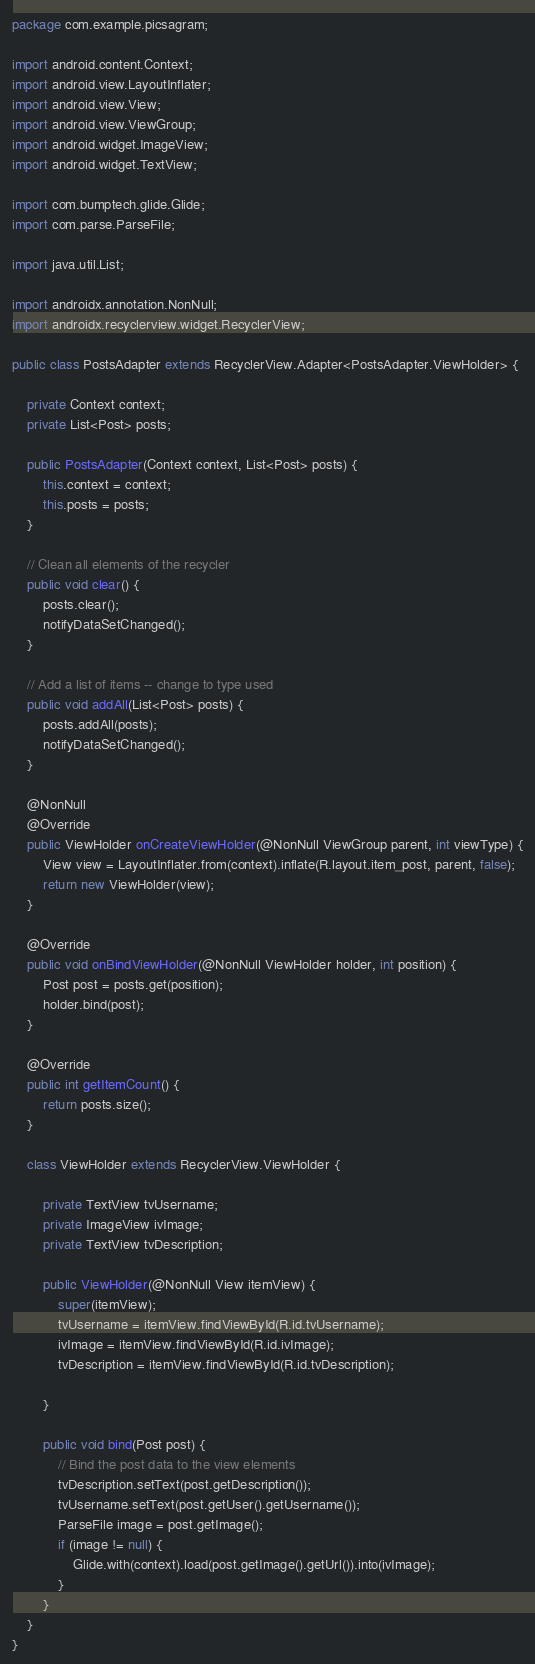<code> <loc_0><loc_0><loc_500><loc_500><_Java_>package com.example.picsagram;

import android.content.Context;
import android.view.LayoutInflater;
import android.view.View;
import android.view.ViewGroup;
import android.widget.ImageView;
import android.widget.TextView;

import com.bumptech.glide.Glide;
import com.parse.ParseFile;

import java.util.List;

import androidx.annotation.NonNull;
import androidx.recyclerview.widget.RecyclerView;

public class PostsAdapter extends RecyclerView.Adapter<PostsAdapter.ViewHolder> {

    private Context context;
    private List<Post> posts;

    public PostsAdapter(Context context, List<Post> posts) {
        this.context = context;
        this.posts = posts;
    }

    // Clean all elements of the recycler
    public void clear() {
        posts.clear();
        notifyDataSetChanged();
    }

    // Add a list of items -- change to type used
    public void addAll(List<Post> posts) {
        posts.addAll(posts);
        notifyDataSetChanged();
    }

    @NonNull
    @Override
    public ViewHolder onCreateViewHolder(@NonNull ViewGroup parent, int viewType) {
        View view = LayoutInflater.from(context).inflate(R.layout.item_post, parent, false);
        return new ViewHolder(view);
    }

    @Override
    public void onBindViewHolder(@NonNull ViewHolder holder, int position) {
        Post post = posts.get(position);
        holder.bind(post);
    }

    @Override
    public int getItemCount() {
        return posts.size();
    }

    class ViewHolder extends RecyclerView.ViewHolder {

        private TextView tvUsername;
        private ImageView ivImage;
        private TextView tvDescription;

        public ViewHolder(@NonNull View itemView) {
            super(itemView);
            tvUsername = itemView.findViewById(R.id.tvUsername);
            ivImage = itemView.findViewById(R.id.ivImage);
            tvDescription = itemView.findViewById(R.id.tvDescription);

        }

        public void bind(Post post) {
            // Bind the post data to the view elements
            tvDescription.setText(post.getDescription());
            tvUsername.setText(post.getUser().getUsername());
            ParseFile image = post.getImage();
            if (image != null) {
                Glide.with(context).load(post.getImage().getUrl()).into(ivImage);
            }
        }
    }
}
</code> 